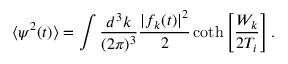<formula> <loc_0><loc_0><loc_500><loc_500>\langle \psi ^ { 2 } ( t ) \rangle = \int \frac { d ^ { 3 } k } { ( 2 \pi ) ^ { 3 } } \frac { | f _ { k } ( t ) | ^ { 2 } } { 2 } \coth \left [ \frac { W _ { k } } { 2 T _ { i } } \right ] .</formula> 